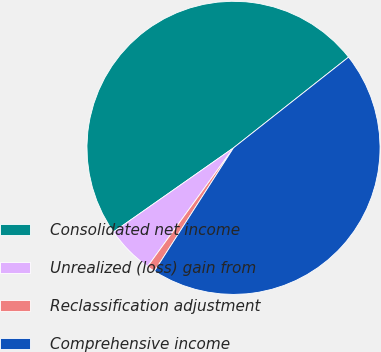Convert chart to OTSL. <chart><loc_0><loc_0><loc_500><loc_500><pie_chart><fcel>Consolidated net income<fcel>Unrealized (loss) gain from<fcel>Reclassification adjustment<fcel>Comprehensive income<nl><fcel>49.1%<fcel>5.3%<fcel>0.9%<fcel>44.7%<nl></chart> 